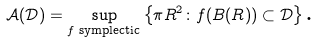<formula> <loc_0><loc_0><loc_500><loc_500>\mathcal { A } ( \mathcal { D } ) = \sup _ { f \text { symplectic} } \left \{ \pi R ^ { 2 } \colon f ( B ( R ) ) \subset \mathcal { D } \right \} \text {.}</formula> 